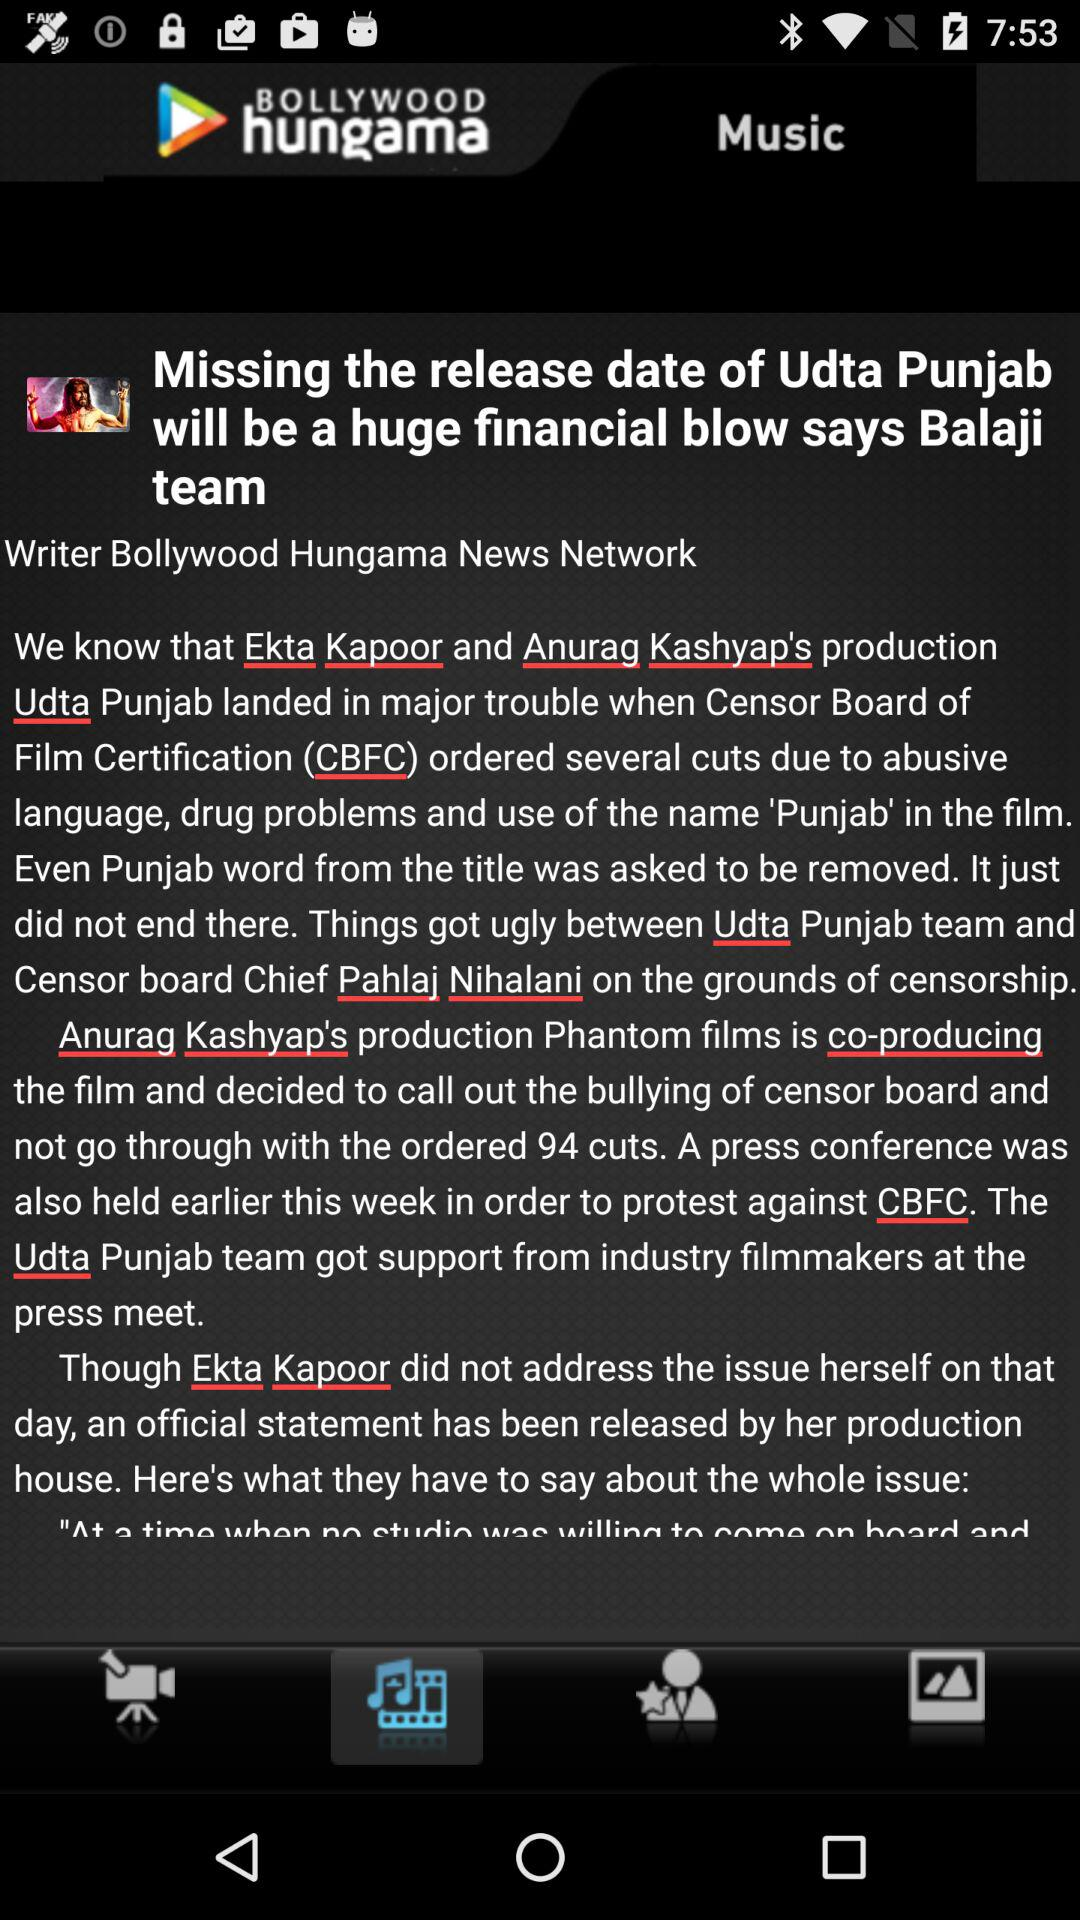What is the headline of the article? The headline of the article is "Missing the release date of Udta Punjab will be a huge financial blow says Balaji team". 